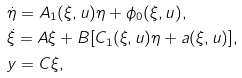Convert formula to latex. <formula><loc_0><loc_0><loc_500><loc_500>& \dot { \eta } = A _ { 1 } ( \xi , u ) \eta + \phi _ { 0 } ( \xi , u ) , \\ & \dot { \xi } = A \xi + B [ C _ { 1 } ( \xi , u ) \eta + a ( \xi , u ) ] , \\ & y = C \xi ,</formula> 